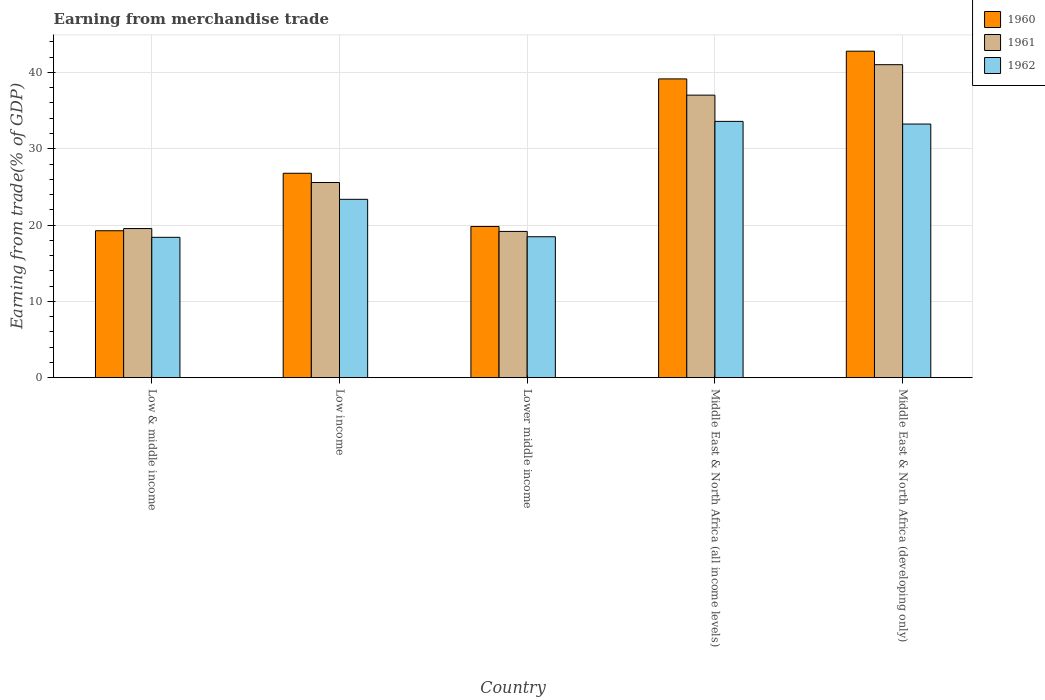Are the number of bars on each tick of the X-axis equal?
Provide a short and direct response. Yes. How many bars are there on the 4th tick from the left?
Make the answer very short. 3. How many bars are there on the 4th tick from the right?
Make the answer very short. 3. What is the label of the 3rd group of bars from the left?
Your response must be concise. Lower middle income. In how many cases, is the number of bars for a given country not equal to the number of legend labels?
Your answer should be very brief. 0. What is the earnings from trade in 1962 in Low & middle income?
Your answer should be very brief. 18.39. Across all countries, what is the maximum earnings from trade in 1962?
Give a very brief answer. 33.59. Across all countries, what is the minimum earnings from trade in 1962?
Provide a succinct answer. 18.39. In which country was the earnings from trade in 1962 maximum?
Offer a very short reply. Middle East & North Africa (all income levels). What is the total earnings from trade in 1960 in the graph?
Your response must be concise. 147.79. What is the difference between the earnings from trade in 1962 in Low & middle income and that in Middle East & North Africa (all income levels)?
Give a very brief answer. -15.19. What is the difference between the earnings from trade in 1960 in Low & middle income and the earnings from trade in 1961 in Middle East & North Africa (all income levels)?
Offer a very short reply. -17.77. What is the average earnings from trade in 1962 per country?
Your answer should be compact. 25.41. What is the difference between the earnings from trade of/in 1962 and earnings from trade of/in 1961 in Middle East & North Africa (all income levels)?
Offer a terse response. -3.44. What is the ratio of the earnings from trade in 1960 in Low & middle income to that in Middle East & North Africa (all income levels)?
Provide a succinct answer. 0.49. What is the difference between the highest and the second highest earnings from trade in 1960?
Keep it short and to the point. 16. What is the difference between the highest and the lowest earnings from trade in 1960?
Your response must be concise. 23.53. In how many countries, is the earnings from trade in 1961 greater than the average earnings from trade in 1961 taken over all countries?
Your answer should be very brief. 2. Is the sum of the earnings from trade in 1961 in Low income and Lower middle income greater than the maximum earnings from trade in 1960 across all countries?
Provide a short and direct response. Yes. What does the 2nd bar from the left in Lower middle income represents?
Keep it short and to the point. 1961. How many countries are there in the graph?
Give a very brief answer. 5. What is the difference between two consecutive major ticks on the Y-axis?
Provide a succinct answer. 10. Does the graph contain any zero values?
Provide a short and direct response. No. Does the graph contain grids?
Provide a succinct answer. Yes. How many legend labels are there?
Provide a succinct answer. 3. What is the title of the graph?
Your answer should be compact. Earning from merchandise trade. What is the label or title of the Y-axis?
Your answer should be very brief. Earning from trade(% of GDP). What is the Earning from trade(% of GDP) of 1960 in Low & middle income?
Your response must be concise. 19.26. What is the Earning from trade(% of GDP) of 1961 in Low & middle income?
Keep it short and to the point. 19.54. What is the Earning from trade(% of GDP) in 1962 in Low & middle income?
Your answer should be compact. 18.39. What is the Earning from trade(% of GDP) of 1960 in Low income?
Give a very brief answer. 26.79. What is the Earning from trade(% of GDP) in 1961 in Low income?
Keep it short and to the point. 25.57. What is the Earning from trade(% of GDP) of 1962 in Low income?
Keep it short and to the point. 23.37. What is the Earning from trade(% of GDP) of 1960 in Lower middle income?
Your answer should be compact. 19.81. What is the Earning from trade(% of GDP) of 1961 in Lower middle income?
Make the answer very short. 19.17. What is the Earning from trade(% of GDP) in 1962 in Lower middle income?
Your response must be concise. 18.47. What is the Earning from trade(% of GDP) of 1960 in Middle East & North Africa (all income levels)?
Make the answer very short. 39.15. What is the Earning from trade(% of GDP) in 1961 in Middle East & North Africa (all income levels)?
Give a very brief answer. 37.03. What is the Earning from trade(% of GDP) of 1962 in Middle East & North Africa (all income levels)?
Offer a very short reply. 33.59. What is the Earning from trade(% of GDP) in 1960 in Middle East & North Africa (developing only)?
Provide a succinct answer. 42.78. What is the Earning from trade(% of GDP) in 1961 in Middle East & North Africa (developing only)?
Offer a terse response. 41.02. What is the Earning from trade(% of GDP) in 1962 in Middle East & North Africa (developing only)?
Ensure brevity in your answer.  33.24. Across all countries, what is the maximum Earning from trade(% of GDP) in 1960?
Give a very brief answer. 42.78. Across all countries, what is the maximum Earning from trade(% of GDP) in 1961?
Provide a succinct answer. 41.02. Across all countries, what is the maximum Earning from trade(% of GDP) in 1962?
Give a very brief answer. 33.59. Across all countries, what is the minimum Earning from trade(% of GDP) of 1960?
Provide a succinct answer. 19.26. Across all countries, what is the minimum Earning from trade(% of GDP) in 1961?
Your answer should be very brief. 19.17. Across all countries, what is the minimum Earning from trade(% of GDP) in 1962?
Provide a succinct answer. 18.39. What is the total Earning from trade(% of GDP) in 1960 in the graph?
Give a very brief answer. 147.79. What is the total Earning from trade(% of GDP) in 1961 in the graph?
Make the answer very short. 142.33. What is the total Earning from trade(% of GDP) in 1962 in the graph?
Keep it short and to the point. 127.06. What is the difference between the Earning from trade(% of GDP) of 1960 in Low & middle income and that in Low income?
Provide a succinct answer. -7.53. What is the difference between the Earning from trade(% of GDP) in 1961 in Low & middle income and that in Low income?
Give a very brief answer. -6.03. What is the difference between the Earning from trade(% of GDP) of 1962 in Low & middle income and that in Low income?
Provide a succinct answer. -4.98. What is the difference between the Earning from trade(% of GDP) of 1960 in Low & middle income and that in Lower middle income?
Provide a short and direct response. -0.56. What is the difference between the Earning from trade(% of GDP) of 1961 in Low & middle income and that in Lower middle income?
Your answer should be compact. 0.37. What is the difference between the Earning from trade(% of GDP) in 1962 in Low & middle income and that in Lower middle income?
Ensure brevity in your answer.  -0.07. What is the difference between the Earning from trade(% of GDP) in 1960 in Low & middle income and that in Middle East & North Africa (all income levels)?
Provide a short and direct response. -19.9. What is the difference between the Earning from trade(% of GDP) of 1961 in Low & middle income and that in Middle East & North Africa (all income levels)?
Your answer should be very brief. -17.49. What is the difference between the Earning from trade(% of GDP) of 1962 in Low & middle income and that in Middle East & North Africa (all income levels)?
Make the answer very short. -15.19. What is the difference between the Earning from trade(% of GDP) in 1960 in Low & middle income and that in Middle East & North Africa (developing only)?
Give a very brief answer. -23.53. What is the difference between the Earning from trade(% of GDP) of 1961 in Low & middle income and that in Middle East & North Africa (developing only)?
Provide a succinct answer. -21.48. What is the difference between the Earning from trade(% of GDP) of 1962 in Low & middle income and that in Middle East & North Africa (developing only)?
Make the answer very short. -14.84. What is the difference between the Earning from trade(% of GDP) in 1960 in Low income and that in Lower middle income?
Make the answer very short. 6.97. What is the difference between the Earning from trade(% of GDP) of 1961 in Low income and that in Lower middle income?
Your response must be concise. 6.41. What is the difference between the Earning from trade(% of GDP) in 1962 in Low income and that in Lower middle income?
Your answer should be very brief. 4.9. What is the difference between the Earning from trade(% of GDP) of 1960 in Low income and that in Middle East & North Africa (all income levels)?
Provide a short and direct response. -12.37. What is the difference between the Earning from trade(% of GDP) of 1961 in Low income and that in Middle East & North Africa (all income levels)?
Your answer should be compact. -11.45. What is the difference between the Earning from trade(% of GDP) of 1962 in Low income and that in Middle East & North Africa (all income levels)?
Provide a succinct answer. -10.21. What is the difference between the Earning from trade(% of GDP) of 1960 in Low income and that in Middle East & North Africa (developing only)?
Offer a very short reply. -16. What is the difference between the Earning from trade(% of GDP) of 1961 in Low income and that in Middle East & North Africa (developing only)?
Give a very brief answer. -15.44. What is the difference between the Earning from trade(% of GDP) of 1962 in Low income and that in Middle East & North Africa (developing only)?
Offer a very short reply. -9.87. What is the difference between the Earning from trade(% of GDP) of 1960 in Lower middle income and that in Middle East & North Africa (all income levels)?
Your answer should be compact. -19.34. What is the difference between the Earning from trade(% of GDP) of 1961 in Lower middle income and that in Middle East & North Africa (all income levels)?
Your response must be concise. -17.86. What is the difference between the Earning from trade(% of GDP) in 1962 in Lower middle income and that in Middle East & North Africa (all income levels)?
Your response must be concise. -15.12. What is the difference between the Earning from trade(% of GDP) of 1960 in Lower middle income and that in Middle East & North Africa (developing only)?
Your response must be concise. -22.97. What is the difference between the Earning from trade(% of GDP) in 1961 in Lower middle income and that in Middle East & North Africa (developing only)?
Give a very brief answer. -21.85. What is the difference between the Earning from trade(% of GDP) in 1962 in Lower middle income and that in Middle East & North Africa (developing only)?
Make the answer very short. -14.77. What is the difference between the Earning from trade(% of GDP) in 1960 in Middle East & North Africa (all income levels) and that in Middle East & North Africa (developing only)?
Provide a short and direct response. -3.63. What is the difference between the Earning from trade(% of GDP) of 1961 in Middle East & North Africa (all income levels) and that in Middle East & North Africa (developing only)?
Make the answer very short. -3.99. What is the difference between the Earning from trade(% of GDP) in 1962 in Middle East & North Africa (all income levels) and that in Middle East & North Africa (developing only)?
Ensure brevity in your answer.  0.35. What is the difference between the Earning from trade(% of GDP) of 1960 in Low & middle income and the Earning from trade(% of GDP) of 1961 in Low income?
Give a very brief answer. -6.32. What is the difference between the Earning from trade(% of GDP) in 1960 in Low & middle income and the Earning from trade(% of GDP) in 1962 in Low income?
Make the answer very short. -4.12. What is the difference between the Earning from trade(% of GDP) of 1961 in Low & middle income and the Earning from trade(% of GDP) of 1962 in Low income?
Make the answer very short. -3.83. What is the difference between the Earning from trade(% of GDP) in 1960 in Low & middle income and the Earning from trade(% of GDP) in 1961 in Lower middle income?
Make the answer very short. 0.09. What is the difference between the Earning from trade(% of GDP) in 1960 in Low & middle income and the Earning from trade(% of GDP) in 1962 in Lower middle income?
Your answer should be compact. 0.79. What is the difference between the Earning from trade(% of GDP) of 1961 in Low & middle income and the Earning from trade(% of GDP) of 1962 in Lower middle income?
Offer a terse response. 1.07. What is the difference between the Earning from trade(% of GDP) in 1960 in Low & middle income and the Earning from trade(% of GDP) in 1961 in Middle East & North Africa (all income levels)?
Offer a very short reply. -17.77. What is the difference between the Earning from trade(% of GDP) in 1960 in Low & middle income and the Earning from trade(% of GDP) in 1962 in Middle East & North Africa (all income levels)?
Your answer should be very brief. -14.33. What is the difference between the Earning from trade(% of GDP) in 1961 in Low & middle income and the Earning from trade(% of GDP) in 1962 in Middle East & North Africa (all income levels)?
Provide a short and direct response. -14.05. What is the difference between the Earning from trade(% of GDP) of 1960 in Low & middle income and the Earning from trade(% of GDP) of 1961 in Middle East & North Africa (developing only)?
Your response must be concise. -21.76. What is the difference between the Earning from trade(% of GDP) in 1960 in Low & middle income and the Earning from trade(% of GDP) in 1962 in Middle East & North Africa (developing only)?
Give a very brief answer. -13.98. What is the difference between the Earning from trade(% of GDP) of 1961 in Low & middle income and the Earning from trade(% of GDP) of 1962 in Middle East & North Africa (developing only)?
Your response must be concise. -13.7. What is the difference between the Earning from trade(% of GDP) in 1960 in Low income and the Earning from trade(% of GDP) in 1961 in Lower middle income?
Your answer should be very brief. 7.62. What is the difference between the Earning from trade(% of GDP) of 1960 in Low income and the Earning from trade(% of GDP) of 1962 in Lower middle income?
Make the answer very short. 8.32. What is the difference between the Earning from trade(% of GDP) of 1961 in Low income and the Earning from trade(% of GDP) of 1962 in Lower middle income?
Your answer should be very brief. 7.11. What is the difference between the Earning from trade(% of GDP) in 1960 in Low income and the Earning from trade(% of GDP) in 1961 in Middle East & North Africa (all income levels)?
Your answer should be very brief. -10.24. What is the difference between the Earning from trade(% of GDP) of 1960 in Low income and the Earning from trade(% of GDP) of 1962 in Middle East & North Africa (all income levels)?
Give a very brief answer. -6.8. What is the difference between the Earning from trade(% of GDP) in 1961 in Low income and the Earning from trade(% of GDP) in 1962 in Middle East & North Africa (all income levels)?
Keep it short and to the point. -8.01. What is the difference between the Earning from trade(% of GDP) in 1960 in Low income and the Earning from trade(% of GDP) in 1961 in Middle East & North Africa (developing only)?
Provide a succinct answer. -14.23. What is the difference between the Earning from trade(% of GDP) in 1960 in Low income and the Earning from trade(% of GDP) in 1962 in Middle East & North Africa (developing only)?
Offer a very short reply. -6.45. What is the difference between the Earning from trade(% of GDP) of 1961 in Low income and the Earning from trade(% of GDP) of 1962 in Middle East & North Africa (developing only)?
Offer a terse response. -7.66. What is the difference between the Earning from trade(% of GDP) of 1960 in Lower middle income and the Earning from trade(% of GDP) of 1961 in Middle East & North Africa (all income levels)?
Give a very brief answer. -17.21. What is the difference between the Earning from trade(% of GDP) of 1960 in Lower middle income and the Earning from trade(% of GDP) of 1962 in Middle East & North Africa (all income levels)?
Provide a succinct answer. -13.77. What is the difference between the Earning from trade(% of GDP) of 1961 in Lower middle income and the Earning from trade(% of GDP) of 1962 in Middle East & North Africa (all income levels)?
Provide a short and direct response. -14.42. What is the difference between the Earning from trade(% of GDP) of 1960 in Lower middle income and the Earning from trade(% of GDP) of 1961 in Middle East & North Africa (developing only)?
Offer a terse response. -21.2. What is the difference between the Earning from trade(% of GDP) in 1960 in Lower middle income and the Earning from trade(% of GDP) in 1962 in Middle East & North Africa (developing only)?
Offer a very short reply. -13.42. What is the difference between the Earning from trade(% of GDP) in 1961 in Lower middle income and the Earning from trade(% of GDP) in 1962 in Middle East & North Africa (developing only)?
Offer a terse response. -14.07. What is the difference between the Earning from trade(% of GDP) in 1960 in Middle East & North Africa (all income levels) and the Earning from trade(% of GDP) in 1961 in Middle East & North Africa (developing only)?
Offer a terse response. -1.86. What is the difference between the Earning from trade(% of GDP) of 1960 in Middle East & North Africa (all income levels) and the Earning from trade(% of GDP) of 1962 in Middle East & North Africa (developing only)?
Your answer should be very brief. 5.92. What is the difference between the Earning from trade(% of GDP) in 1961 in Middle East & North Africa (all income levels) and the Earning from trade(% of GDP) in 1962 in Middle East & North Africa (developing only)?
Your response must be concise. 3.79. What is the average Earning from trade(% of GDP) of 1960 per country?
Keep it short and to the point. 29.56. What is the average Earning from trade(% of GDP) in 1961 per country?
Make the answer very short. 28.47. What is the average Earning from trade(% of GDP) in 1962 per country?
Your response must be concise. 25.41. What is the difference between the Earning from trade(% of GDP) of 1960 and Earning from trade(% of GDP) of 1961 in Low & middle income?
Ensure brevity in your answer.  -0.29. What is the difference between the Earning from trade(% of GDP) in 1960 and Earning from trade(% of GDP) in 1962 in Low & middle income?
Keep it short and to the point. 0.86. What is the difference between the Earning from trade(% of GDP) of 1961 and Earning from trade(% of GDP) of 1962 in Low & middle income?
Offer a very short reply. 1.15. What is the difference between the Earning from trade(% of GDP) in 1960 and Earning from trade(% of GDP) in 1961 in Low income?
Give a very brief answer. 1.21. What is the difference between the Earning from trade(% of GDP) in 1960 and Earning from trade(% of GDP) in 1962 in Low income?
Provide a succinct answer. 3.41. What is the difference between the Earning from trade(% of GDP) in 1961 and Earning from trade(% of GDP) in 1962 in Low income?
Your response must be concise. 2.2. What is the difference between the Earning from trade(% of GDP) in 1960 and Earning from trade(% of GDP) in 1961 in Lower middle income?
Make the answer very short. 0.65. What is the difference between the Earning from trade(% of GDP) in 1960 and Earning from trade(% of GDP) in 1962 in Lower middle income?
Keep it short and to the point. 1.35. What is the difference between the Earning from trade(% of GDP) of 1961 and Earning from trade(% of GDP) of 1962 in Lower middle income?
Your answer should be compact. 0.7. What is the difference between the Earning from trade(% of GDP) in 1960 and Earning from trade(% of GDP) in 1961 in Middle East & North Africa (all income levels)?
Provide a succinct answer. 2.13. What is the difference between the Earning from trade(% of GDP) in 1960 and Earning from trade(% of GDP) in 1962 in Middle East & North Africa (all income levels)?
Keep it short and to the point. 5.57. What is the difference between the Earning from trade(% of GDP) in 1961 and Earning from trade(% of GDP) in 1962 in Middle East & North Africa (all income levels)?
Offer a terse response. 3.44. What is the difference between the Earning from trade(% of GDP) in 1960 and Earning from trade(% of GDP) in 1961 in Middle East & North Africa (developing only)?
Offer a terse response. 1.77. What is the difference between the Earning from trade(% of GDP) of 1960 and Earning from trade(% of GDP) of 1962 in Middle East & North Africa (developing only)?
Offer a terse response. 9.55. What is the difference between the Earning from trade(% of GDP) of 1961 and Earning from trade(% of GDP) of 1962 in Middle East & North Africa (developing only)?
Offer a terse response. 7.78. What is the ratio of the Earning from trade(% of GDP) of 1960 in Low & middle income to that in Low income?
Provide a short and direct response. 0.72. What is the ratio of the Earning from trade(% of GDP) of 1961 in Low & middle income to that in Low income?
Make the answer very short. 0.76. What is the ratio of the Earning from trade(% of GDP) in 1962 in Low & middle income to that in Low income?
Provide a succinct answer. 0.79. What is the ratio of the Earning from trade(% of GDP) in 1960 in Low & middle income to that in Lower middle income?
Make the answer very short. 0.97. What is the ratio of the Earning from trade(% of GDP) in 1961 in Low & middle income to that in Lower middle income?
Ensure brevity in your answer.  1.02. What is the ratio of the Earning from trade(% of GDP) of 1962 in Low & middle income to that in Lower middle income?
Offer a terse response. 1. What is the ratio of the Earning from trade(% of GDP) in 1960 in Low & middle income to that in Middle East & North Africa (all income levels)?
Provide a succinct answer. 0.49. What is the ratio of the Earning from trade(% of GDP) in 1961 in Low & middle income to that in Middle East & North Africa (all income levels)?
Provide a succinct answer. 0.53. What is the ratio of the Earning from trade(% of GDP) in 1962 in Low & middle income to that in Middle East & North Africa (all income levels)?
Ensure brevity in your answer.  0.55. What is the ratio of the Earning from trade(% of GDP) of 1960 in Low & middle income to that in Middle East & North Africa (developing only)?
Give a very brief answer. 0.45. What is the ratio of the Earning from trade(% of GDP) of 1961 in Low & middle income to that in Middle East & North Africa (developing only)?
Provide a short and direct response. 0.48. What is the ratio of the Earning from trade(% of GDP) in 1962 in Low & middle income to that in Middle East & North Africa (developing only)?
Your answer should be compact. 0.55. What is the ratio of the Earning from trade(% of GDP) of 1960 in Low income to that in Lower middle income?
Provide a succinct answer. 1.35. What is the ratio of the Earning from trade(% of GDP) in 1961 in Low income to that in Lower middle income?
Offer a very short reply. 1.33. What is the ratio of the Earning from trade(% of GDP) of 1962 in Low income to that in Lower middle income?
Offer a very short reply. 1.27. What is the ratio of the Earning from trade(% of GDP) of 1960 in Low income to that in Middle East & North Africa (all income levels)?
Provide a succinct answer. 0.68. What is the ratio of the Earning from trade(% of GDP) of 1961 in Low income to that in Middle East & North Africa (all income levels)?
Your answer should be compact. 0.69. What is the ratio of the Earning from trade(% of GDP) of 1962 in Low income to that in Middle East & North Africa (all income levels)?
Offer a very short reply. 0.7. What is the ratio of the Earning from trade(% of GDP) in 1960 in Low income to that in Middle East & North Africa (developing only)?
Keep it short and to the point. 0.63. What is the ratio of the Earning from trade(% of GDP) of 1961 in Low income to that in Middle East & North Africa (developing only)?
Your answer should be very brief. 0.62. What is the ratio of the Earning from trade(% of GDP) in 1962 in Low income to that in Middle East & North Africa (developing only)?
Provide a succinct answer. 0.7. What is the ratio of the Earning from trade(% of GDP) of 1960 in Lower middle income to that in Middle East & North Africa (all income levels)?
Offer a very short reply. 0.51. What is the ratio of the Earning from trade(% of GDP) of 1961 in Lower middle income to that in Middle East & North Africa (all income levels)?
Offer a terse response. 0.52. What is the ratio of the Earning from trade(% of GDP) of 1962 in Lower middle income to that in Middle East & North Africa (all income levels)?
Make the answer very short. 0.55. What is the ratio of the Earning from trade(% of GDP) of 1960 in Lower middle income to that in Middle East & North Africa (developing only)?
Provide a succinct answer. 0.46. What is the ratio of the Earning from trade(% of GDP) in 1961 in Lower middle income to that in Middle East & North Africa (developing only)?
Provide a succinct answer. 0.47. What is the ratio of the Earning from trade(% of GDP) of 1962 in Lower middle income to that in Middle East & North Africa (developing only)?
Your answer should be very brief. 0.56. What is the ratio of the Earning from trade(% of GDP) in 1960 in Middle East & North Africa (all income levels) to that in Middle East & North Africa (developing only)?
Offer a terse response. 0.92. What is the ratio of the Earning from trade(% of GDP) in 1961 in Middle East & North Africa (all income levels) to that in Middle East & North Africa (developing only)?
Give a very brief answer. 0.9. What is the ratio of the Earning from trade(% of GDP) of 1962 in Middle East & North Africa (all income levels) to that in Middle East & North Africa (developing only)?
Keep it short and to the point. 1.01. What is the difference between the highest and the second highest Earning from trade(% of GDP) in 1960?
Your answer should be very brief. 3.63. What is the difference between the highest and the second highest Earning from trade(% of GDP) of 1961?
Offer a terse response. 3.99. What is the difference between the highest and the second highest Earning from trade(% of GDP) in 1962?
Provide a short and direct response. 0.35. What is the difference between the highest and the lowest Earning from trade(% of GDP) in 1960?
Your response must be concise. 23.53. What is the difference between the highest and the lowest Earning from trade(% of GDP) in 1961?
Offer a very short reply. 21.85. What is the difference between the highest and the lowest Earning from trade(% of GDP) in 1962?
Keep it short and to the point. 15.19. 